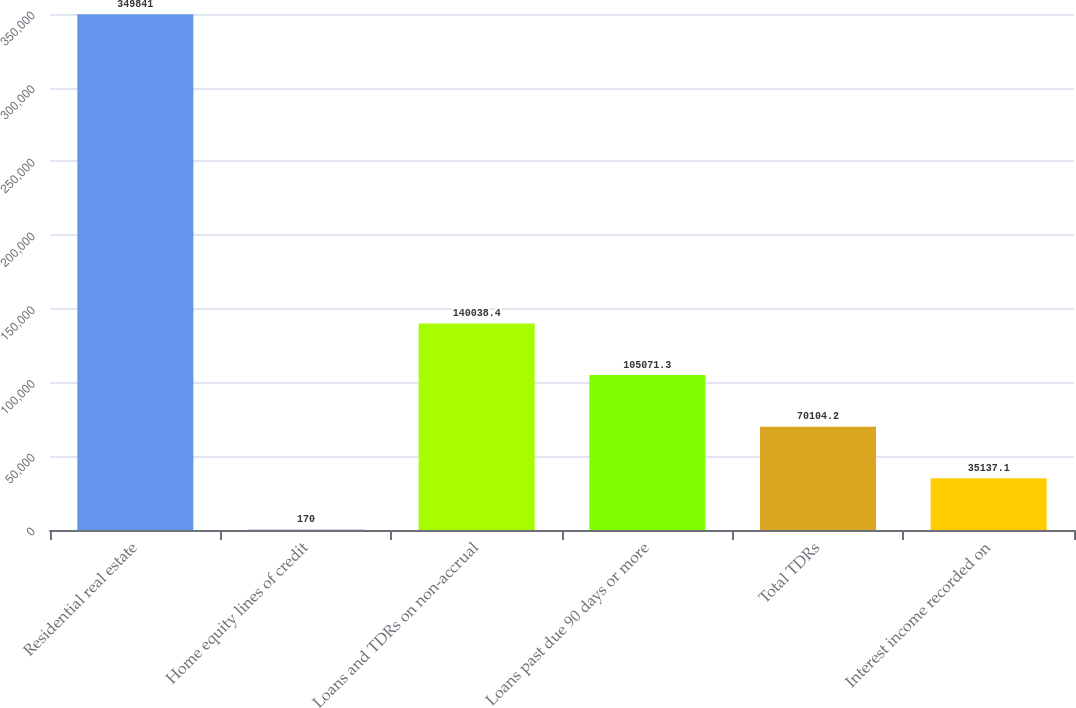Convert chart. <chart><loc_0><loc_0><loc_500><loc_500><bar_chart><fcel>Residential real estate<fcel>Home equity lines of credit<fcel>Loans and TDRs on non-accrual<fcel>Loans past due 90 days or more<fcel>Total TDRs<fcel>Interest income recorded on<nl><fcel>349841<fcel>170<fcel>140038<fcel>105071<fcel>70104.2<fcel>35137.1<nl></chart> 